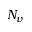<formula> <loc_0><loc_0><loc_500><loc_500>N _ { v }</formula> 